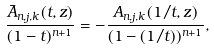Convert formula to latex. <formula><loc_0><loc_0><loc_500><loc_500>\frac { \bar { A } _ { n , j , k } ( t , z ) } { ( 1 - t ) ^ { n + 1 } } = - \frac { A _ { n , j , k } ( 1 / t , z ) } { ( 1 - ( 1 / t ) ) ^ { n + 1 } } ,</formula> 